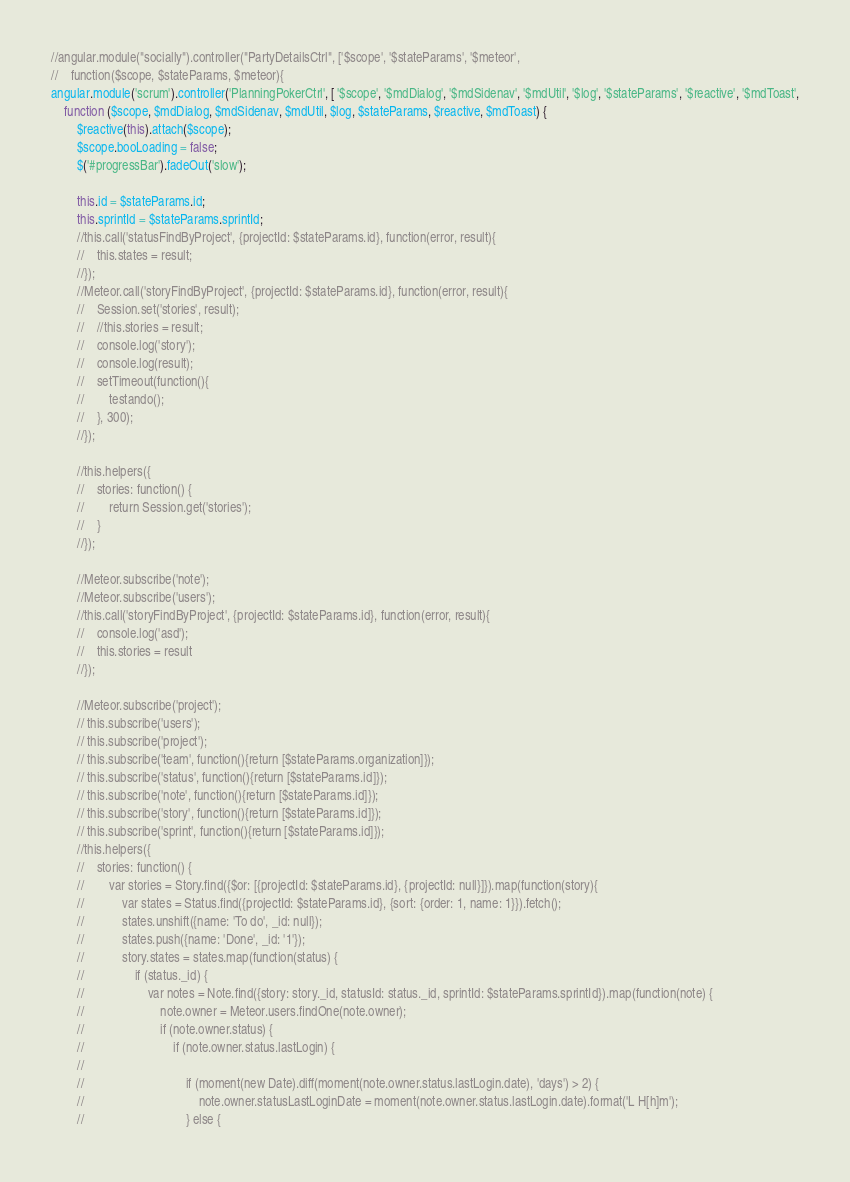Convert code to text. <code><loc_0><loc_0><loc_500><loc_500><_JavaScript_>//angular.module("socially").controller("PartyDetailsCtrl", ['$scope', '$stateParams', '$meteor',
//    function($scope, $stateParams, $meteor){
angular.module('scrum').controller('PlanningPokerCtrl', [ '$scope', '$mdDialog', '$mdSidenav', '$mdUtil', '$log', '$stateParams', '$reactive', '$mdToast',
    function ($scope, $mdDialog, $mdSidenav, $mdUtil, $log, $stateParams, $reactive, $mdToast) {
        $reactive(this).attach($scope);
        $scope.booLoading = false;
        $('#progressBar').fadeOut('slow');

        this.id = $stateParams.id;
        this.sprintId = $stateParams.sprintId;
        //this.call('statusFindByProject', {projectId: $stateParams.id}, function(error, result){
        //    this.states = result;
        //});
        //Meteor.call('storyFindByProject', {projectId: $stateParams.id}, function(error, result){
        //    Session.set('stories', result);
        //    //this.stories = result;
        //    console.log('story');
        //    console.log(result);
        //    setTimeout(function(){
        //        testando();
        //    }, 300);
        //});

        //this.helpers({
        //    stories: function() {
        //        return Session.get('stories');
        //    }
        //});

        //Meteor.subscribe('note');
        //Meteor.subscribe('users');
        //this.call('storyFindByProject', {projectId: $stateParams.id}, function(error, result){
        //    console.log('asd');
        //    this.stories = result
        //});

        //Meteor.subscribe('project');
        // this.subscribe('users');
        // this.subscribe('project');
        // this.subscribe('team', function(){return [$stateParams.organization]});
        // this.subscribe('status', function(){return [$stateParams.id]});
        // this.subscribe('note', function(){return [$stateParams.id]});
        // this.subscribe('story', function(){return [$stateParams.id]});
        // this.subscribe('sprint', function(){return [$stateParams.id]});
        //this.helpers({
        //    stories: function() {
        //        var stories = Story.find({$or: [{projectId: $stateParams.id}, {projectId: null}]}).map(function(story){
        //            var states = Status.find({projectId: $stateParams.id}, {sort: {order: 1, name: 1}}).fetch();
        //            states.unshift({name: 'To do', _id: null});
        //            states.push({name: 'Done', _id: '1'});
        //            story.states = states.map(function(status) {
        //                if (status._id) {
        //                    var notes = Note.find({story: story._id, statusId: status._id, sprintId: $stateParams.sprintId}).map(function(note) {
        //                        note.owner = Meteor.users.findOne(note.owner);
        //                        if (note.owner.status) {
        //                            if (note.owner.status.lastLogin) {
        //
        //                                if (moment(new Date).diff(moment(note.owner.status.lastLogin.date), 'days') > 2) {
        //                                    note.owner.statusLastLoginDate = moment(note.owner.status.lastLogin.date).format('L H[h]m');
        //                                } else {</code> 